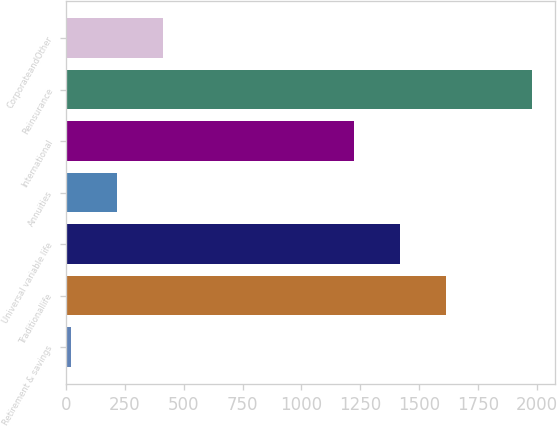Convert chart. <chart><loc_0><loc_0><loc_500><loc_500><bar_chart><fcel>Retirement & savings<fcel>Traditionallife<fcel>Universal variable life<fcel>Annuities<fcel>International<fcel>Reinsurance<fcel>CorporateandOther<nl><fcel>21<fcel>1614.8<fcel>1418.9<fcel>216.9<fcel>1223<fcel>1980<fcel>412.8<nl></chart> 